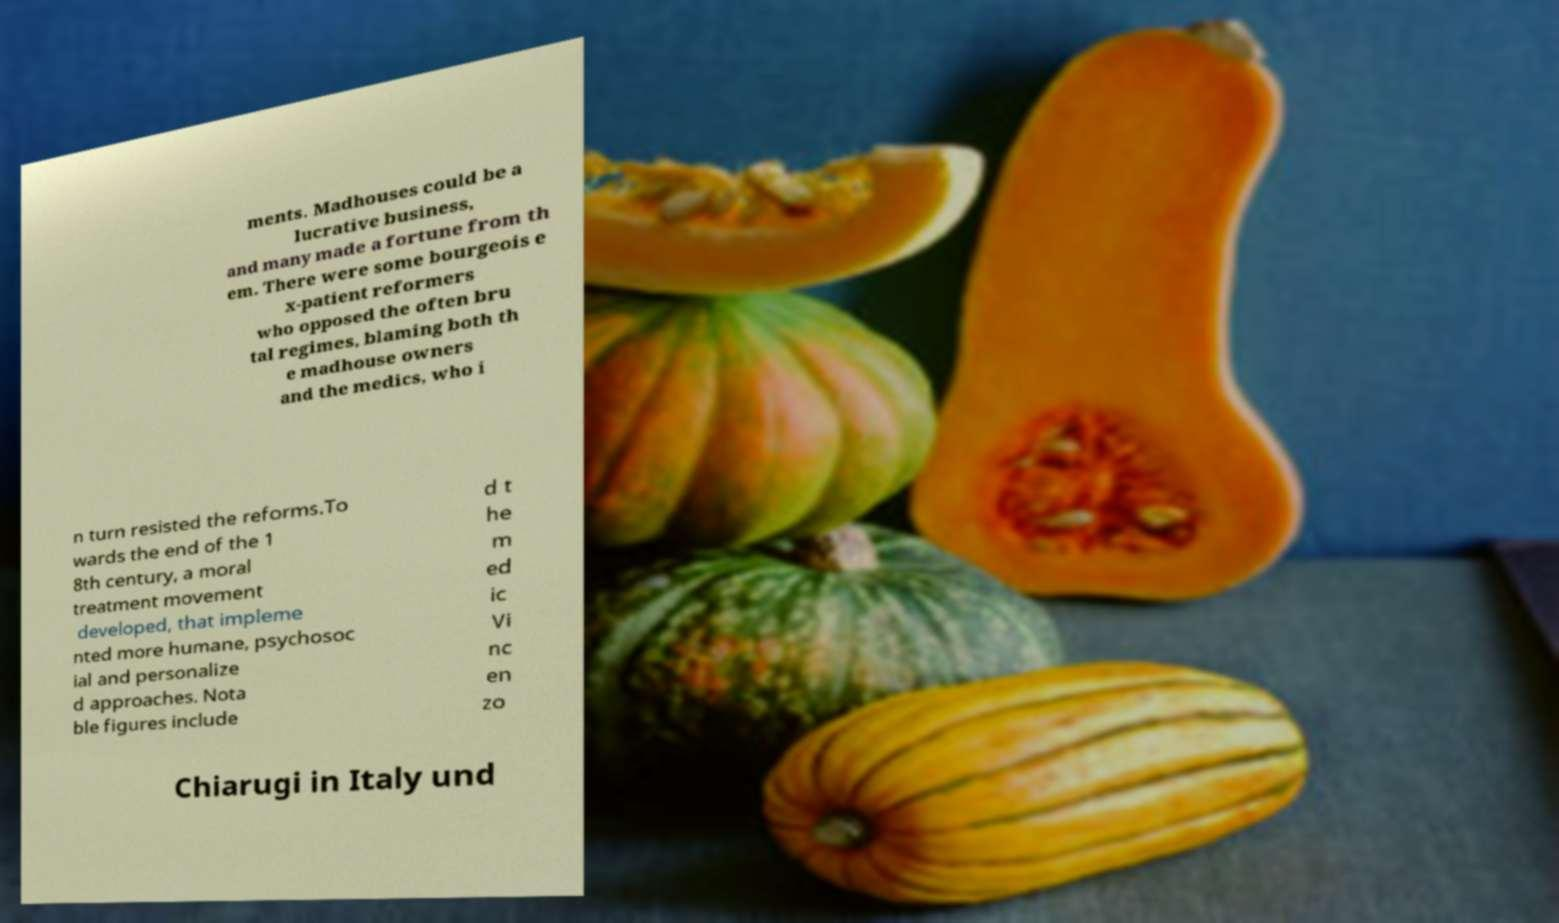What messages or text are displayed in this image? I need them in a readable, typed format. ments. Madhouses could be a lucrative business, and many made a fortune from th em. There were some bourgeois e x-patient reformers who opposed the often bru tal regimes, blaming both th e madhouse owners and the medics, who i n turn resisted the reforms.To wards the end of the 1 8th century, a moral treatment movement developed, that impleme nted more humane, psychosoc ial and personalize d approaches. Nota ble figures include d t he m ed ic Vi nc en zo Chiarugi in Italy und 